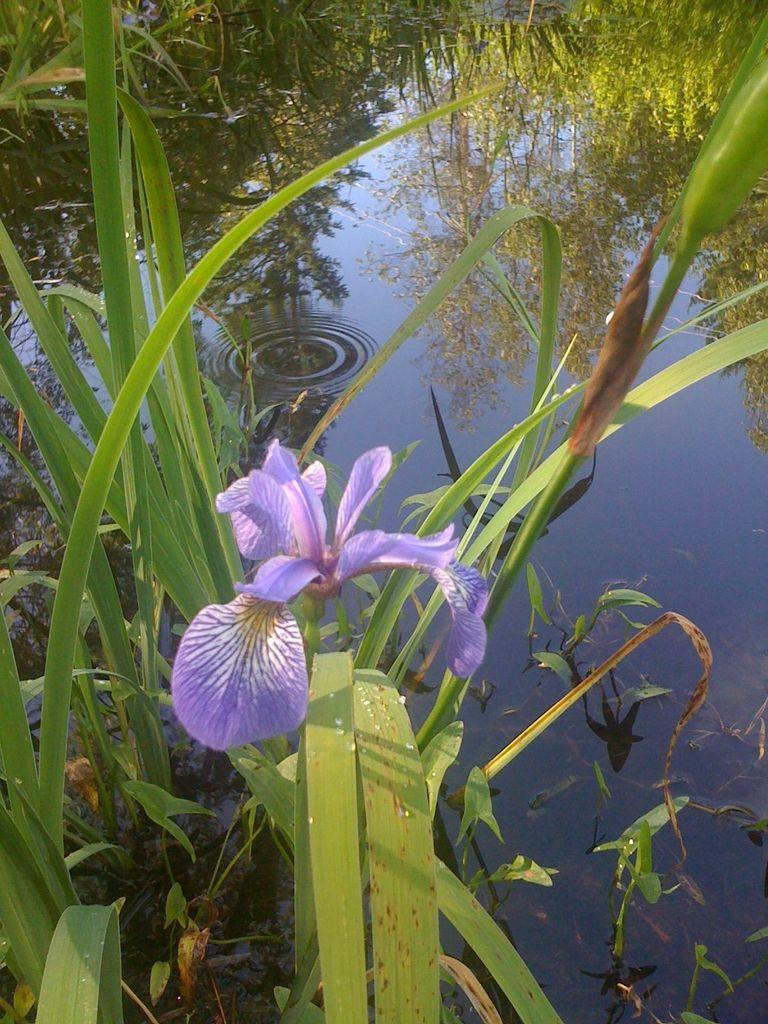What type of plants are in the image? There are plants in the water in the image. How are the plants situated in the image? The plants are in the water. What is the distance between the plants and the visitor in the image? There is no visitor present in the image, so it is not possible to determine the distance between the plants and a visitor. 